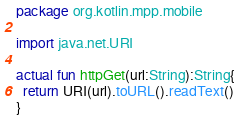<code> <loc_0><loc_0><loc_500><loc_500><_Kotlin_>package org.kotlin.mpp.mobile

import java.net.URI

actual fun httpGet(url:String):String{
  return URI(url).toURL().readText()
}</code> 